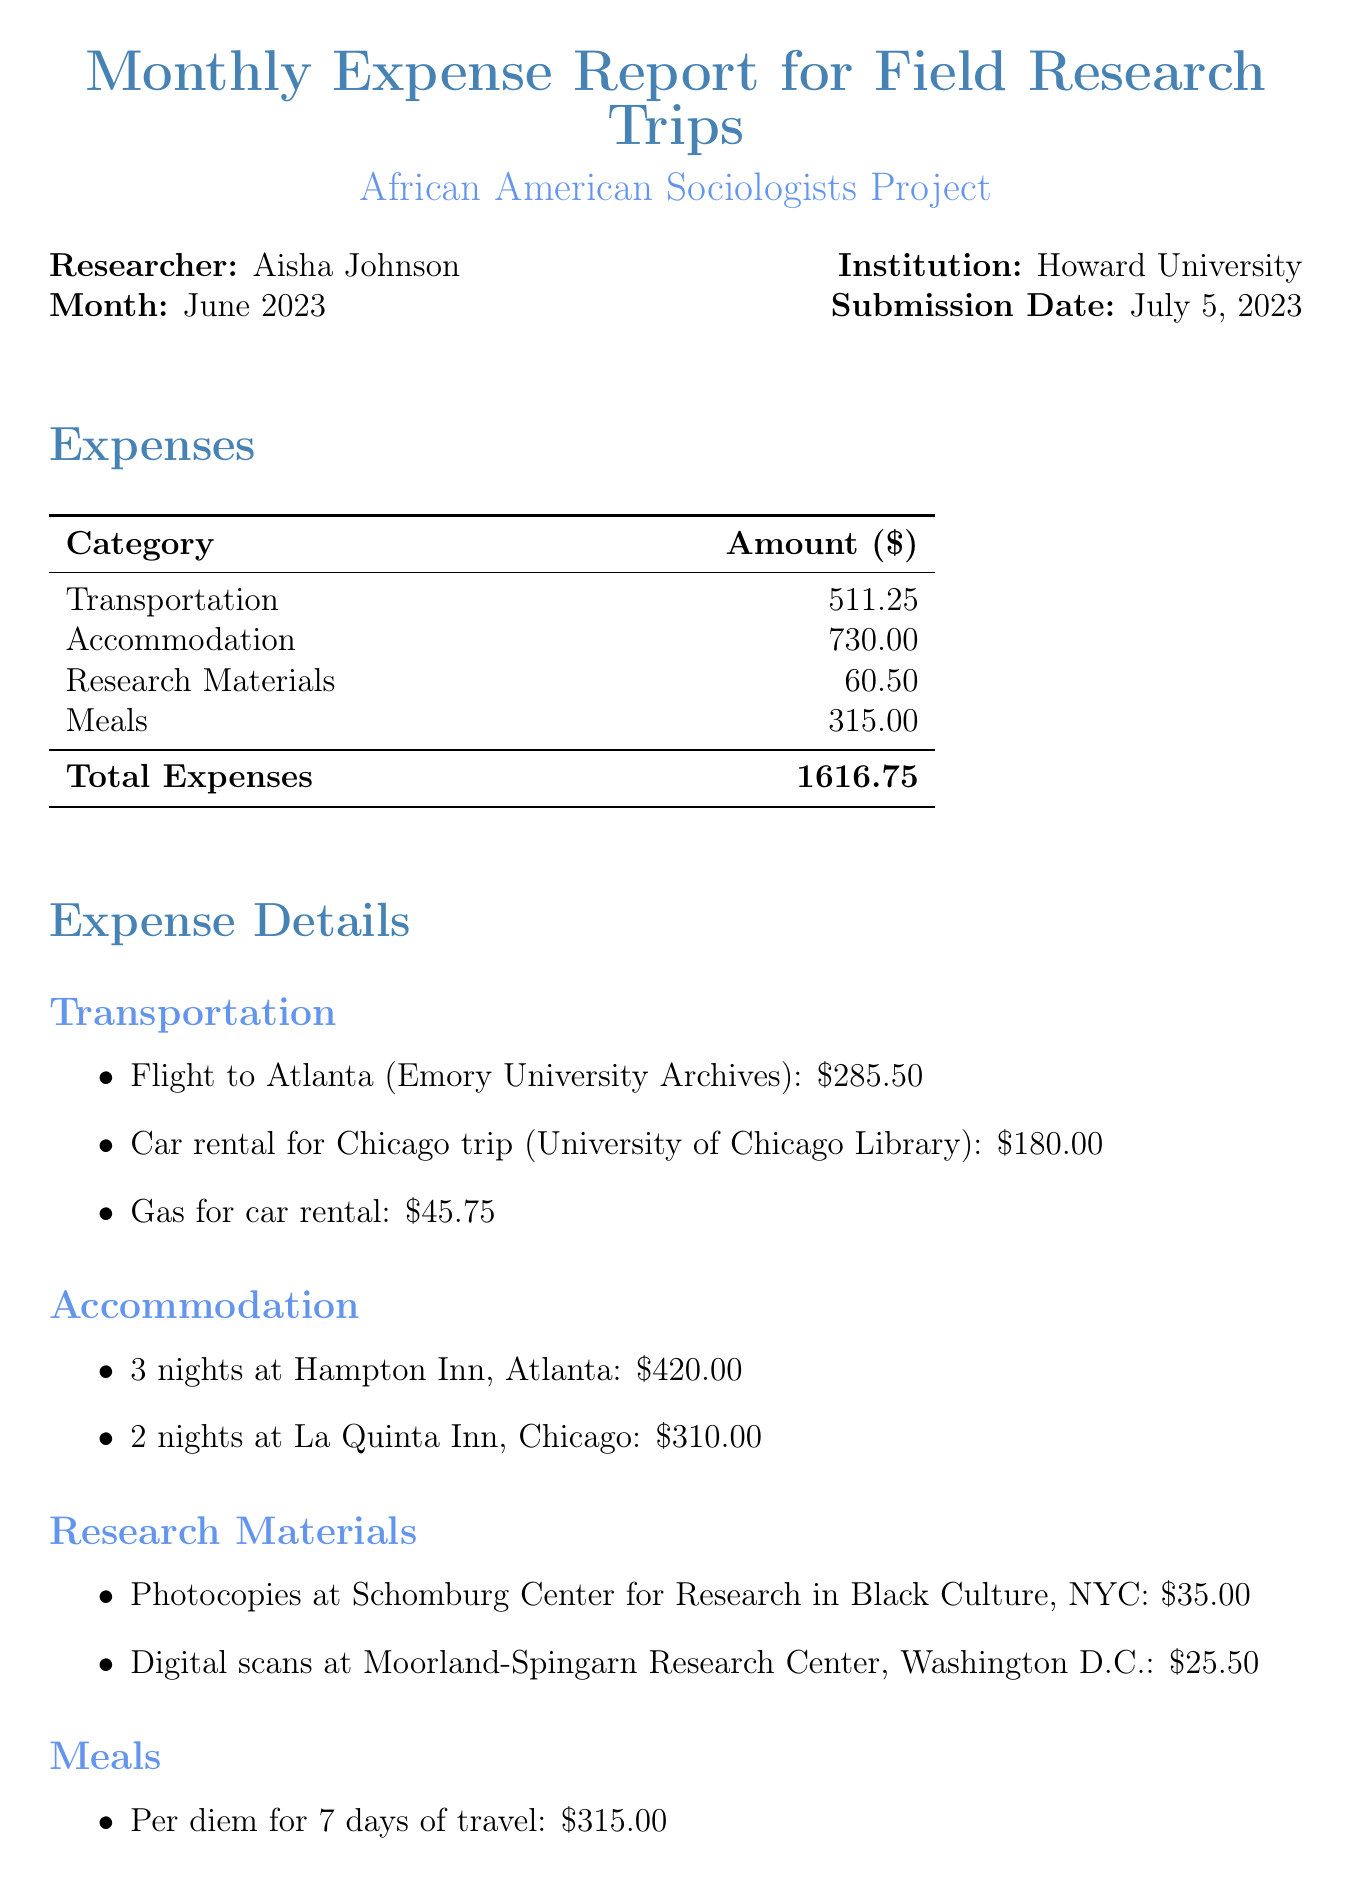what is the researcher’s name? The researcher’s name is explicitly stated in the document, which is Aisha Johnson.
Answer: Aisha Johnson what is the total amount of expenses? The total amount of expenses is summarized at the end of the expenses section, which is $1616.75.
Answer: $1616.75 how many nights did the researcher stay in Atlanta? The document specifies that the researcher stayed for 3 nights at Hampton Inn, Atlanta.
Answer: 3 nights what category has the highest expense? By comparing the expenses listed, the category with the highest expense is Accommodation at $730.00.
Answer: Accommodation what are the two locations mentioned for research materials? The document lists specific locations where research materials were obtained: Schomburg Center for Research in Black Culture and Moorland-Spingarn Research Center.
Answer: Schomburg Center for Research in Black Culture, Moorland-Spingarn Research Center how much was spent on meals? The expense for meals, as indicated in the Meals section, is $315.00.
Answer: $315.00 which month does this expense report pertain to? The month referred to in the expense report is clearly stated as June 2023.
Answer: June 2023 what was the total cost of transportation? The total cost of transportation can be calculated from the listed items, which add up to $511.25.
Answer: $511.25 what is the purpose of the research trips? The purpose of the research trips is briefly described in the notes section, which focuses on archives related to significant sociologists.
Answer: Focused on archives related to W.E.B. Du Bois, E. Franklin Frazier, and Oliver Cox 